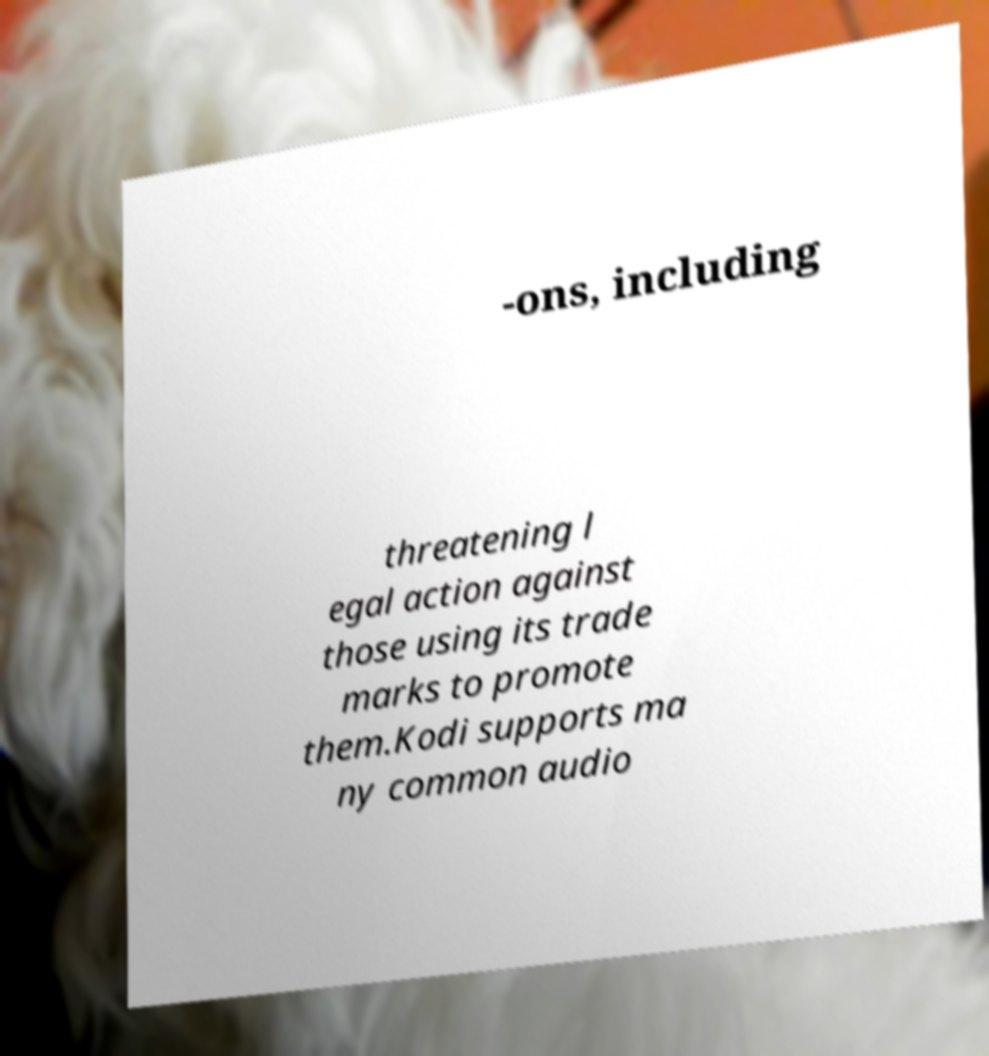Could you extract and type out the text from this image? -ons, including threatening l egal action against those using its trade marks to promote them.Kodi supports ma ny common audio 